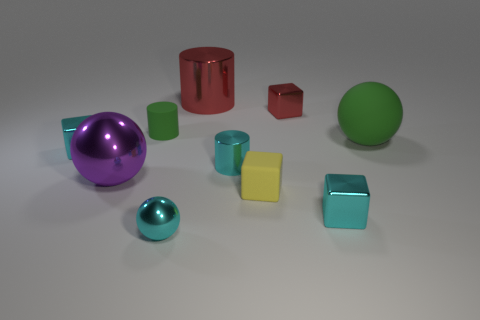Subtract all big spheres. How many spheres are left? 1 Subtract all cyan spheres. How many cyan blocks are left? 2 Subtract all yellow blocks. How many blocks are left? 3 Subtract all spheres. How many objects are left? 7 Add 2 big green rubber balls. How many big green rubber balls exist? 3 Subtract 0 gray cylinders. How many objects are left? 10 Subtract all purple blocks. Subtract all brown cylinders. How many blocks are left? 4 Subtract all metallic balls. Subtract all red metallic objects. How many objects are left? 6 Add 9 cyan cylinders. How many cyan cylinders are left? 10 